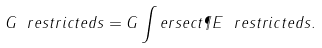<formula> <loc_0><loc_0><loc_500><loc_500>G \ r e s t r i c t e d s = G \int e r s e c t \P E \ r e s t r i c t e d s .</formula> 